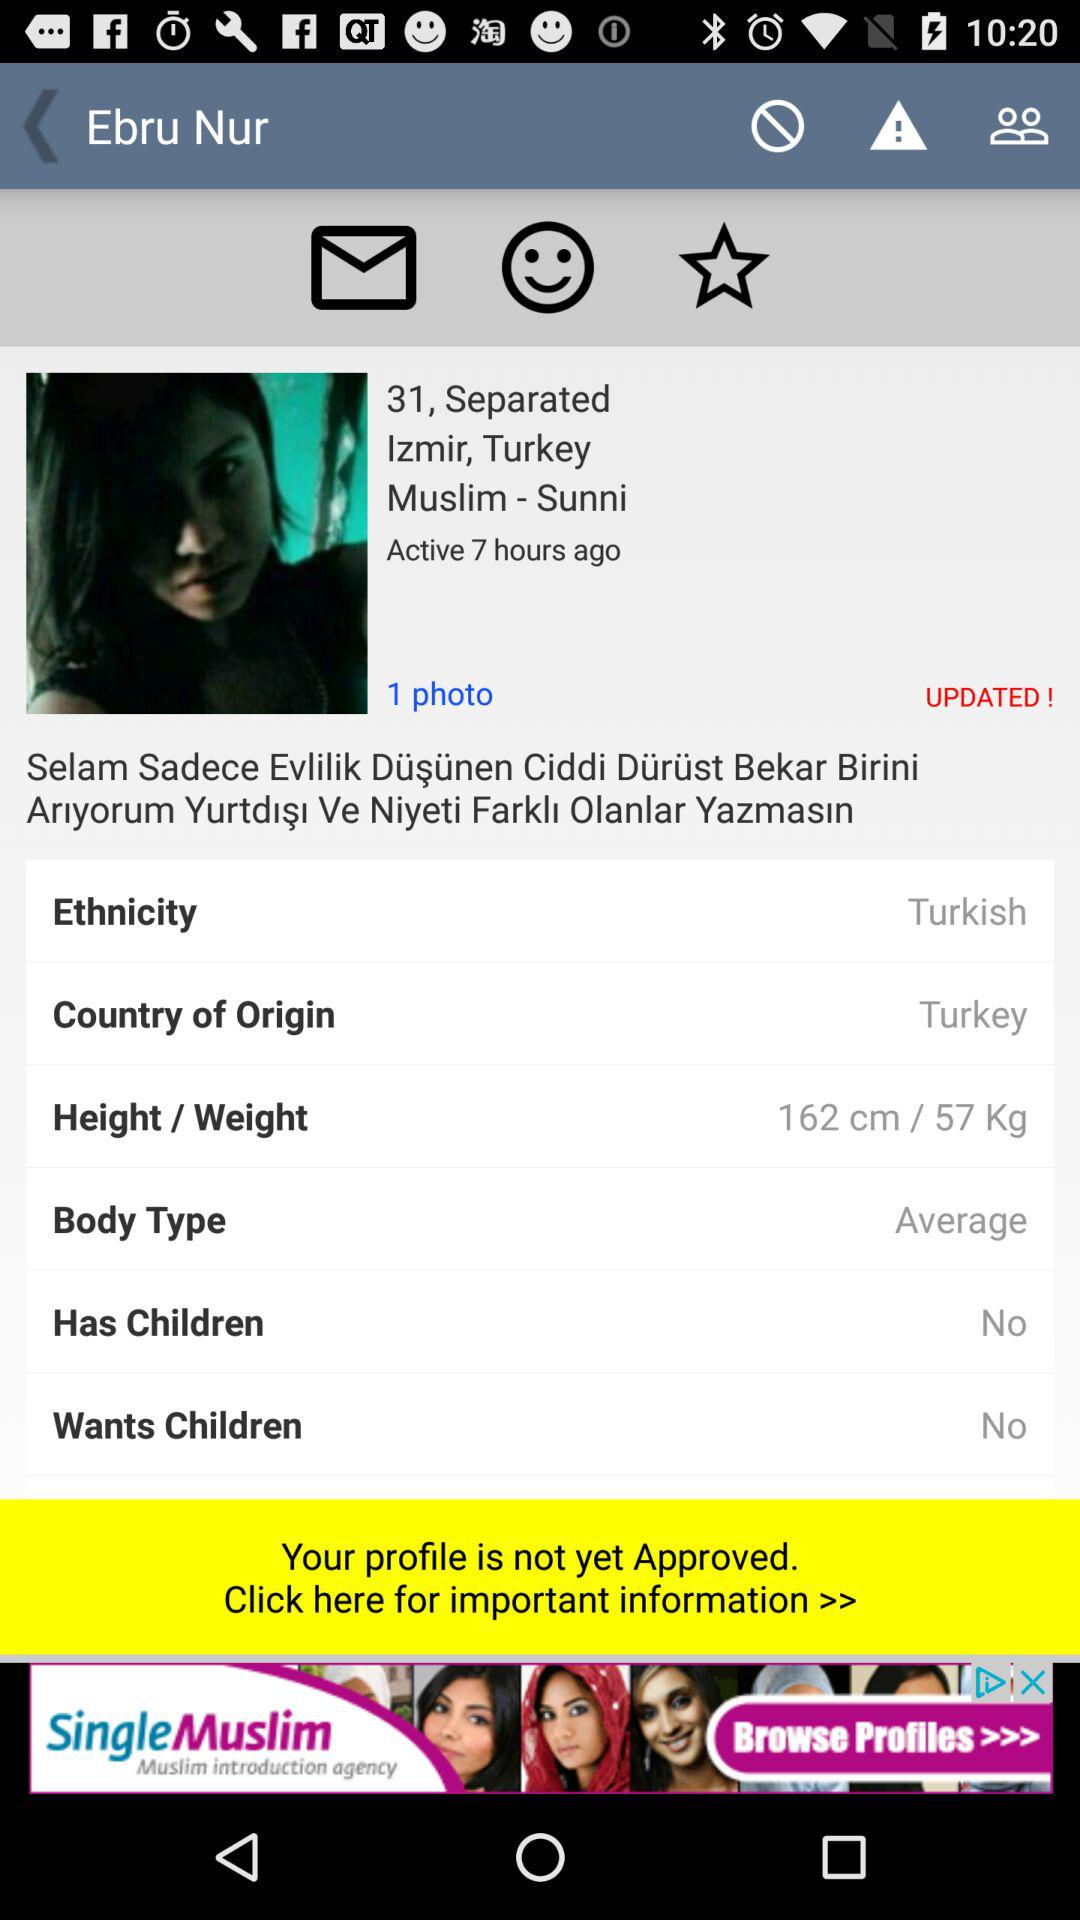What is the religion of the person? The religion of the person is Muslim. 